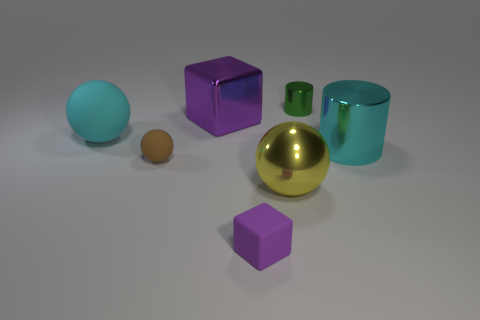Add 1 tiny blue things. How many objects exist? 8 Subtract all tiny brown rubber balls. How many balls are left? 2 Subtract all cylinders. How many objects are left? 5 Subtract 2 balls. How many balls are left? 1 Subtract all yellow balls. Subtract all blue blocks. How many balls are left? 2 Subtract all purple cylinders. How many cyan balls are left? 1 Subtract all small rubber cubes. Subtract all purple shiny blocks. How many objects are left? 5 Add 4 purple metallic things. How many purple metallic things are left? 5 Add 2 tiny purple objects. How many tiny purple objects exist? 3 Subtract all cyan cylinders. How many cylinders are left? 1 